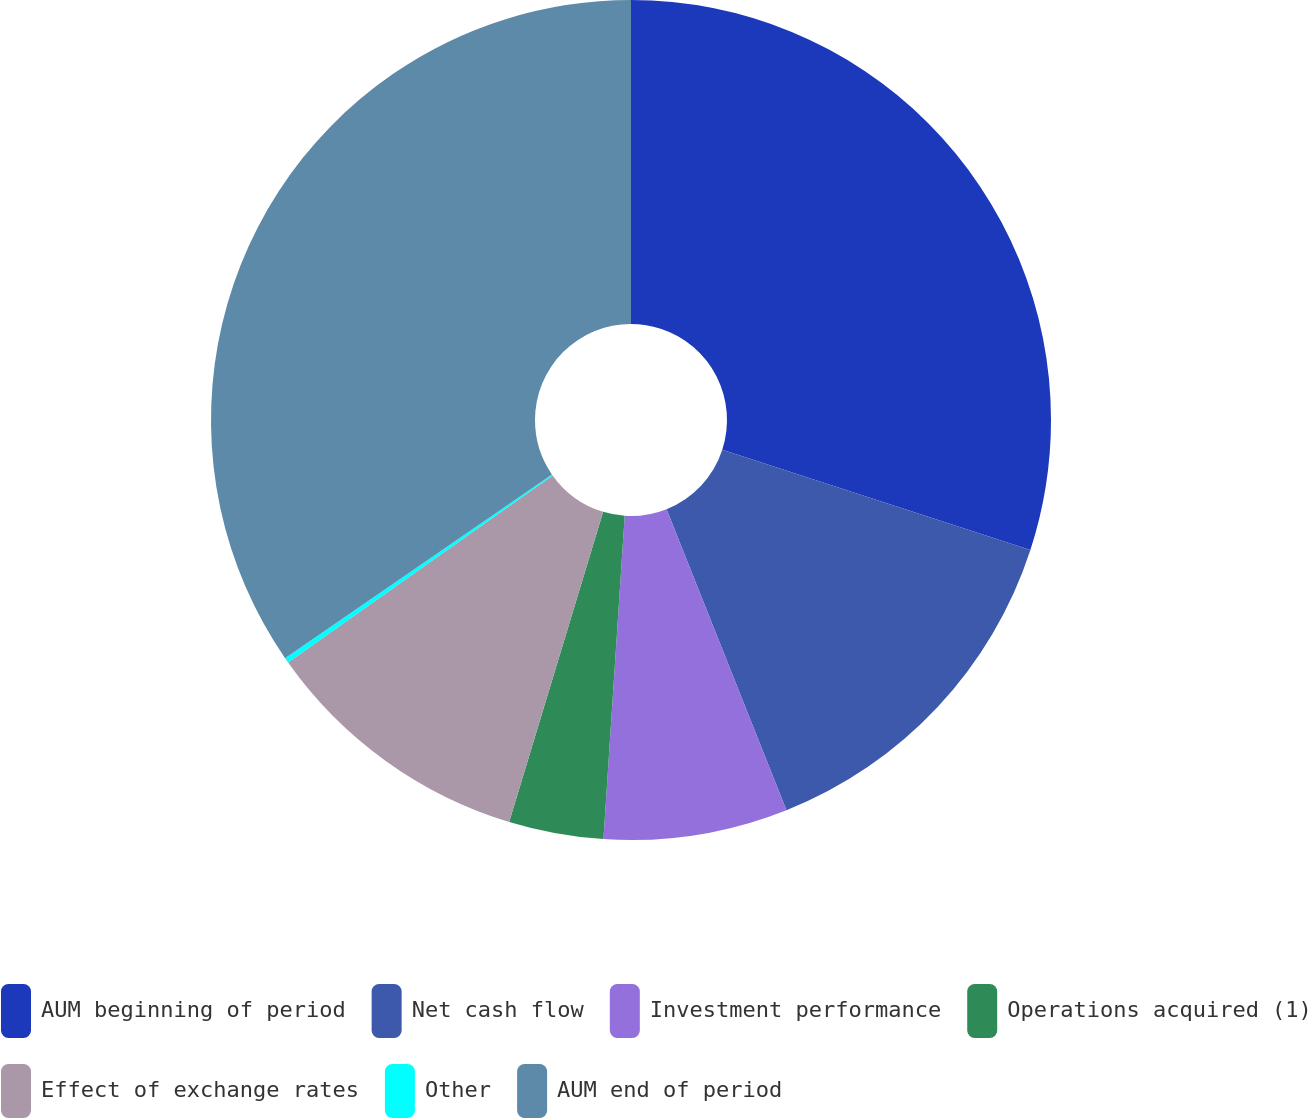<chart> <loc_0><loc_0><loc_500><loc_500><pie_chart><fcel>AUM beginning of period<fcel>Net cash flow<fcel>Investment performance<fcel>Operations acquired (1)<fcel>Effect of exchange rates<fcel>Other<fcel>AUM end of period<nl><fcel>30.01%<fcel>13.96%<fcel>7.08%<fcel>3.64%<fcel>10.52%<fcel>0.2%<fcel>34.6%<nl></chart> 